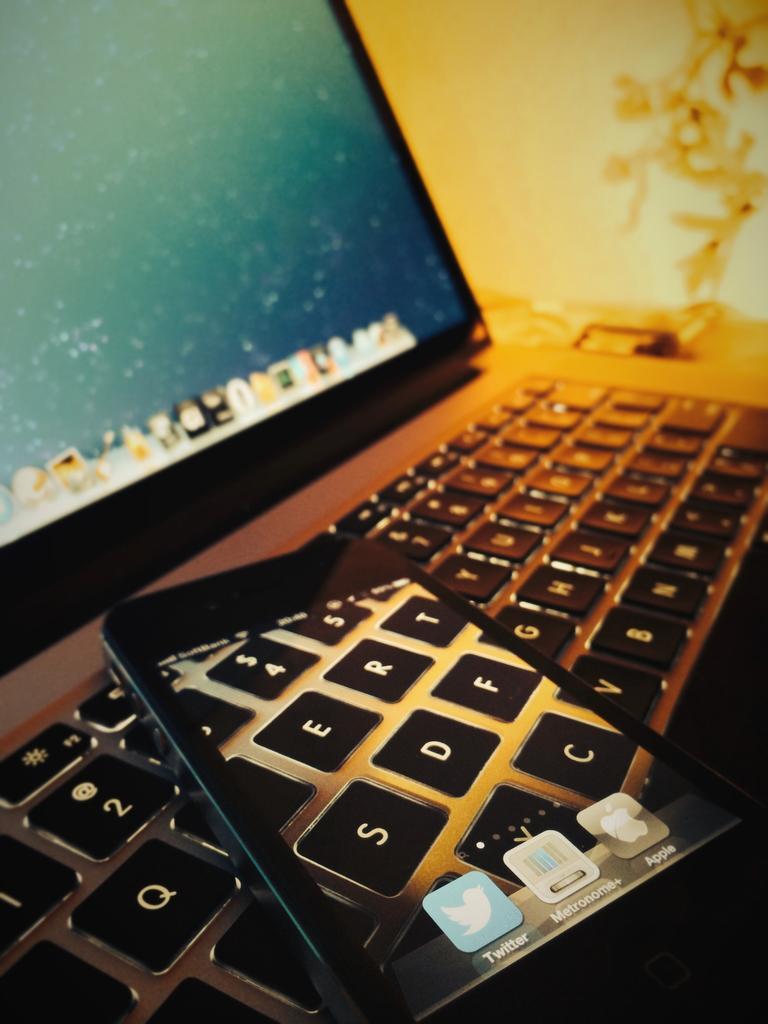Please provide a concise description of this image. This is monitor and a keyboard. 